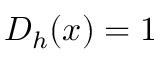<formula> <loc_0><loc_0><loc_500><loc_500>D _ { h } ( x ) = 1</formula> 